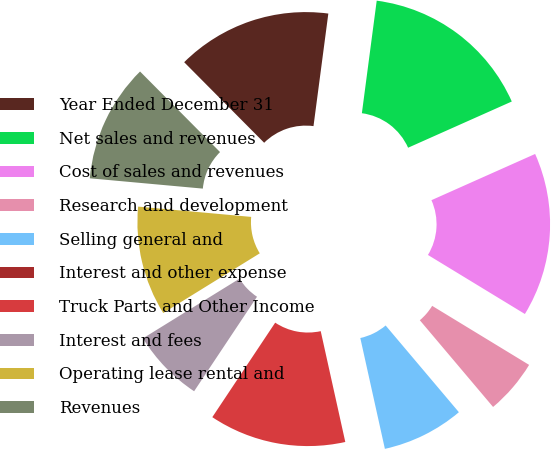Convert chart to OTSL. <chart><loc_0><loc_0><loc_500><loc_500><pie_chart><fcel>Year Ended December 31<fcel>Net sales and revenues<fcel>Cost of sales and revenues<fcel>Research and development<fcel>Selling general and<fcel>Interest and other expense<fcel>Truck Parts and Other Income<fcel>Interest and fees<fcel>Operating lease rental and<fcel>Revenues<nl><fcel>14.53%<fcel>16.24%<fcel>15.38%<fcel>5.13%<fcel>7.69%<fcel>0.0%<fcel>12.82%<fcel>6.84%<fcel>10.26%<fcel>11.11%<nl></chart> 